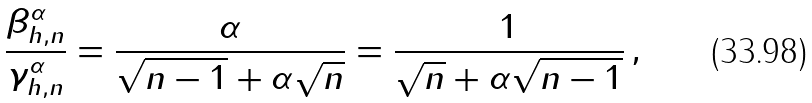<formula> <loc_0><loc_0><loc_500><loc_500>\frac { \beta ^ { \alpha } _ { h , n } } { \gamma ^ { \alpha } _ { h , n } } & = \frac { \alpha } { \sqrt { n - 1 } + \alpha \sqrt { n } } = \frac { 1 } { \sqrt { n } + \alpha \sqrt { n - 1 } } \, ,</formula> 